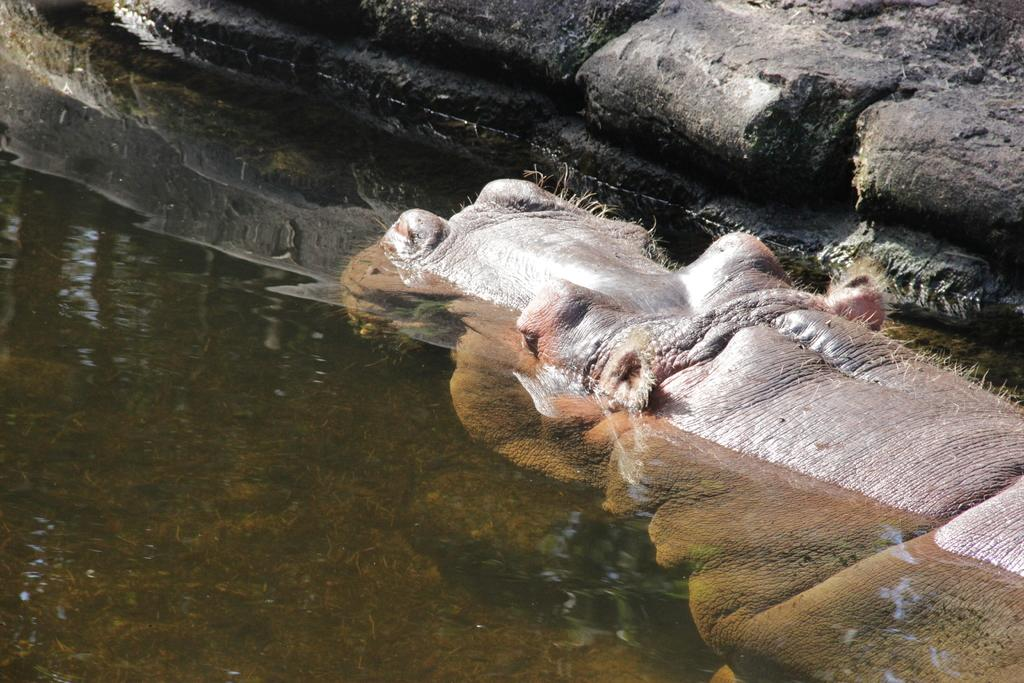What animal is in the water in the image? There is a hippopotamus in the water. What is located near the water in the image? There is a rock on the side of the water. What type of flame can be seen burning on the hippopotamus's back in the image? There is no flame present in the image; it features a hippopotamus in the water and a rock near the water. 